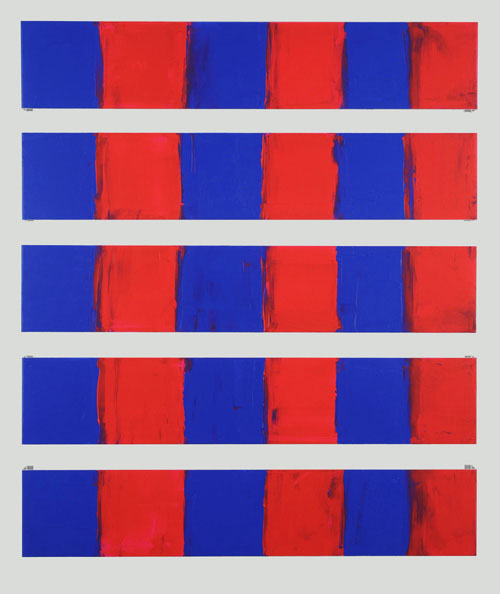What emotions do the colors red and blue evoke in this artwork? The red and blue in the artwork evoke a striking interplay of emotions. Red typically suggests warmth, passion, or even aggression, which contrasts with the calm, rational, and serene connotations of blue. The juxtaposition in each panel may prompt viewers to feel a dynamic tension or a harmonious balance, depending on their personal interpretation. 